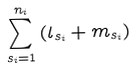Convert formula to latex. <formula><loc_0><loc_0><loc_500><loc_500>\sum _ { { s _ { i } } = 1 } ^ { n _ { i } } \left ( l _ { s _ { i } } + m _ { s _ { i } } \right )</formula> 